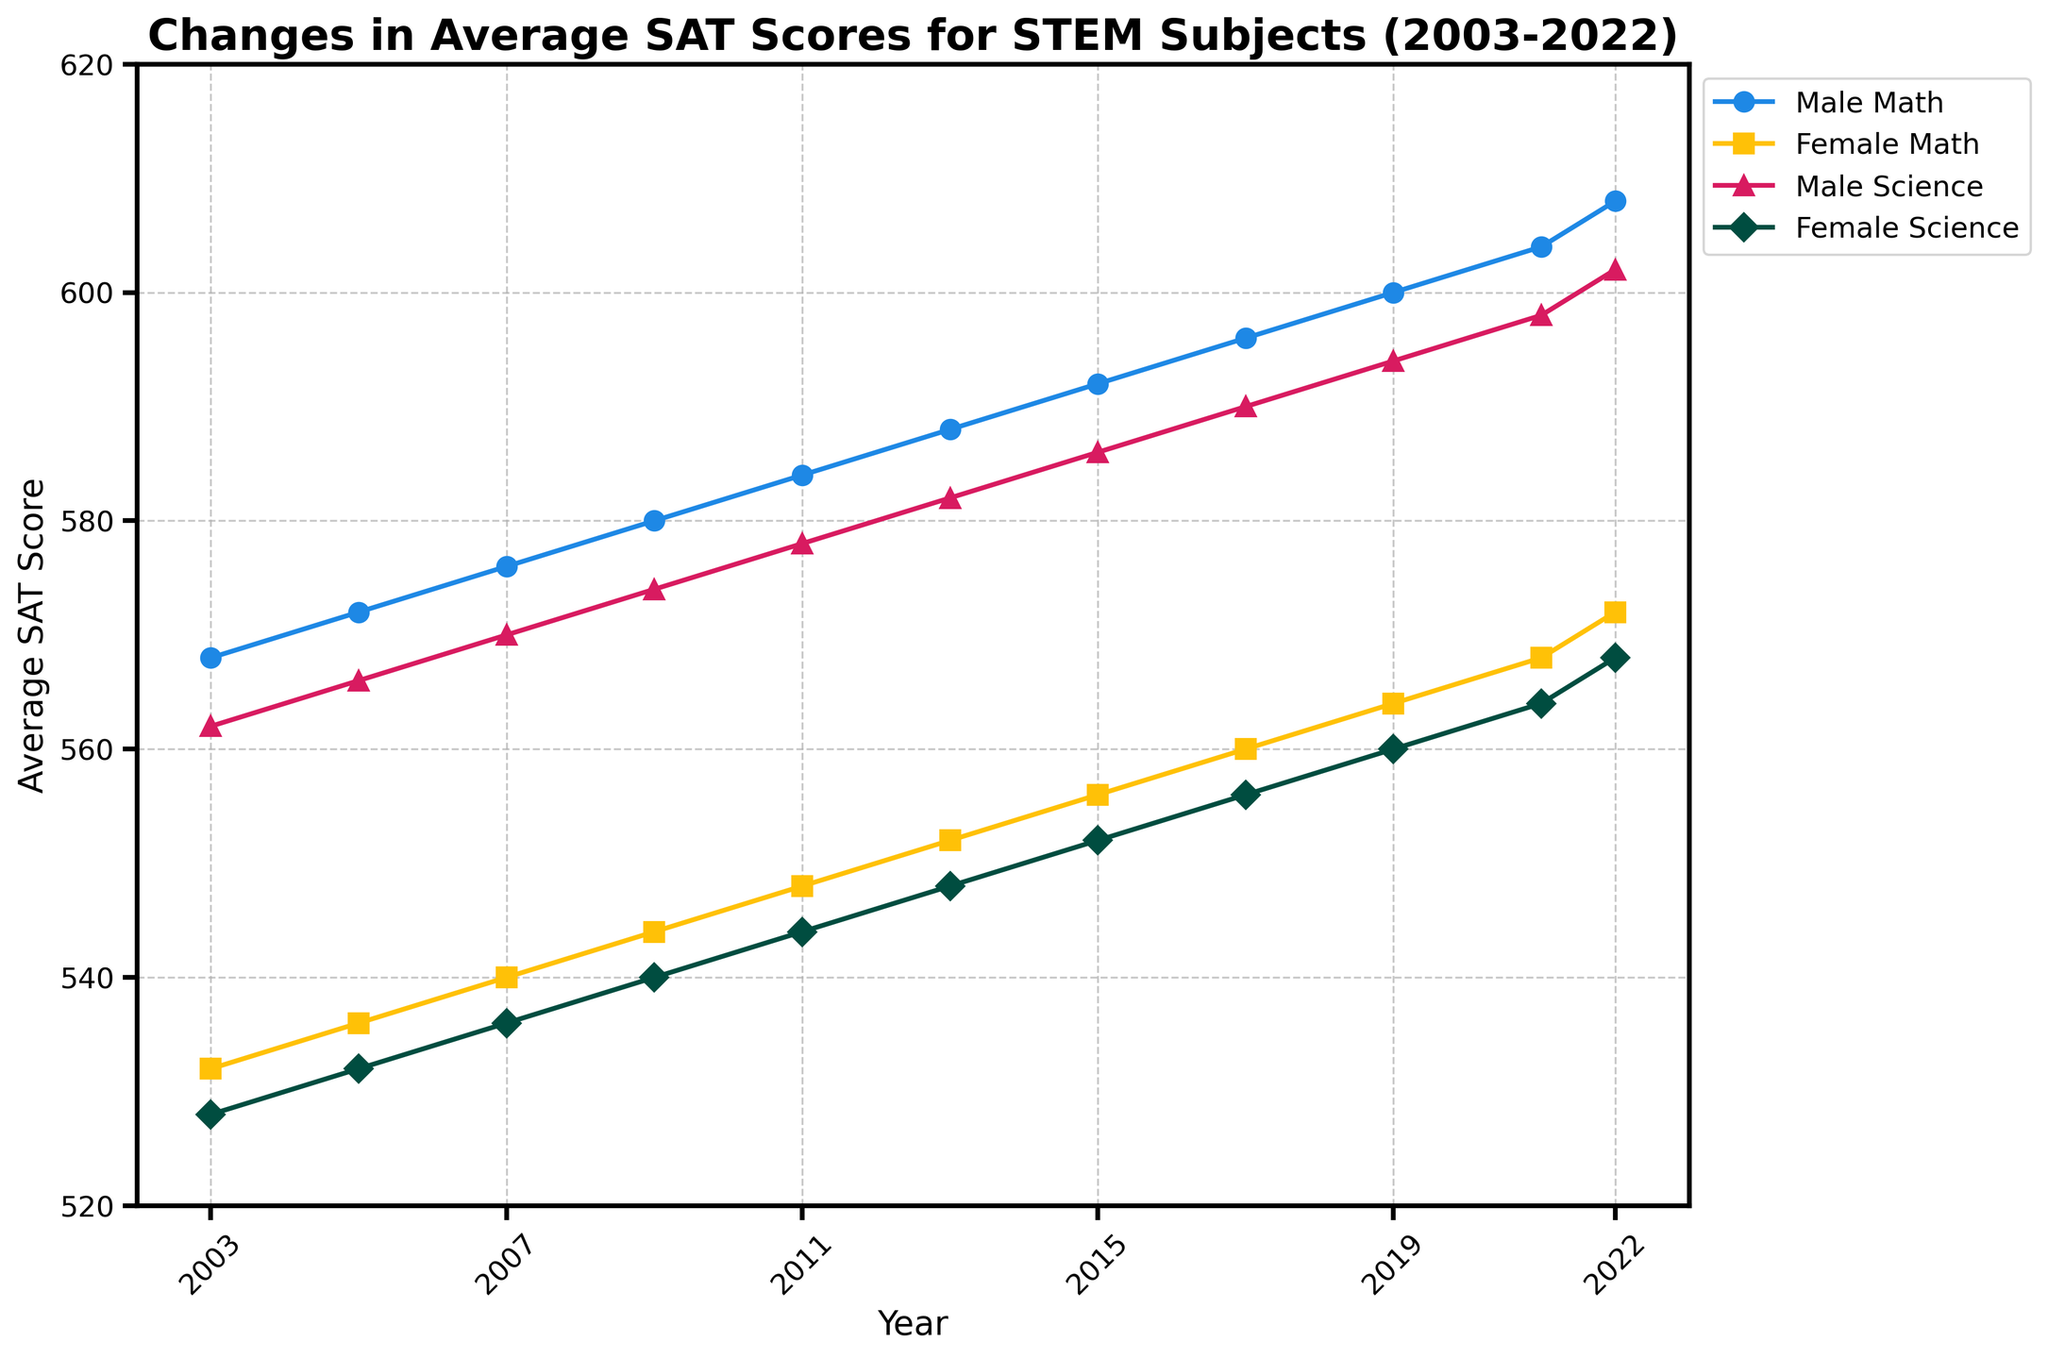What is the average SAT score for Male Math in 2022? To find the average SAT score for Male Math in 2022, simply refer to the Male Math plot and locate the value for the year 2022.
Answer: 608 By how many points did the Female Science SAT score increase from 2003 to 2022? Locate the Female Science scores in 2003 and 2022. The value in 2003 is 528 and in 2022 is 568. The difference is 568 - 528.
Answer: 40 What is the sum of the Male Science SAT scores for 2017 and 2021? Locate the Male Science scores in 2017 and 2021. The values are 590 and 598 respectively. Sum them up: 590 + 598.
Answer: 1188 Which gender had the higher Math SAT score in 2015 and by how many points? Locate the Male Math and Female Math scores for 2015. Male Math is 592 and Female Math is 556. Calculate the difference: 592 - 556.
Answer: Male by 36 points During which year did Female Math SAT scores first surpass 550? Examine the Female Math plot and identify the first year where the score exceeds 550. This happens in 2013.
Answer: 2013 What is the difference between the highest Male Math score and the highest Female Science score within the given years? Identify the highest Male Math score (608 in 2022) and the highest Female Science score (568 in 2022). Calculate the difference: 608 - 568.
Answer: 40 What was the average SAT score for Female Science in odd-numbered years between 2003 and 2021? Identify the Female Science scores for odd-numbered years: 2003 (528), 2005 (532), 2007 (536), 2009 (540), 2011 (544), 2013 (548), 2015 (552), 2017 (556), 2019 (560), and 2021 (564). Sum them: 528 + 532 + 536 + 540 + 544 + 548 + 552 + 556 + 560 + 564 = 5460. There are 10 data points, so the average: 5460 / 10.
Answer: 546 How many years did it take for the Male Science SAT scores to increase by 40 points from 2003? Locate the Male Science score in 2003 (562). Adding 40 points gives 602. Identify the year when Male Science score reaches 602 (2022). Therefore, it took from 2003 to 2022.
Answer: 19 years Did the Female Math SAT score in 2009 surpass or fall below the Male Science score in 2003? Locate the Female Math score in 2009 (544) and the Male Science score in 2003 (562). Compare them: 544 < 562.
Answer: Fall below Which STEM subject had the smallest increase in average SAT scores for males from 2003 to 2022? Compare the increase in scores for Male Math and Male Science from 2003 to 2022. Male Math increased from 568 to 608 (40 points) and Male Science increased from 562 to 602 (40 points). Both increased by the same amount, so there is no smallest increase.
Answer: Both had the same increase 